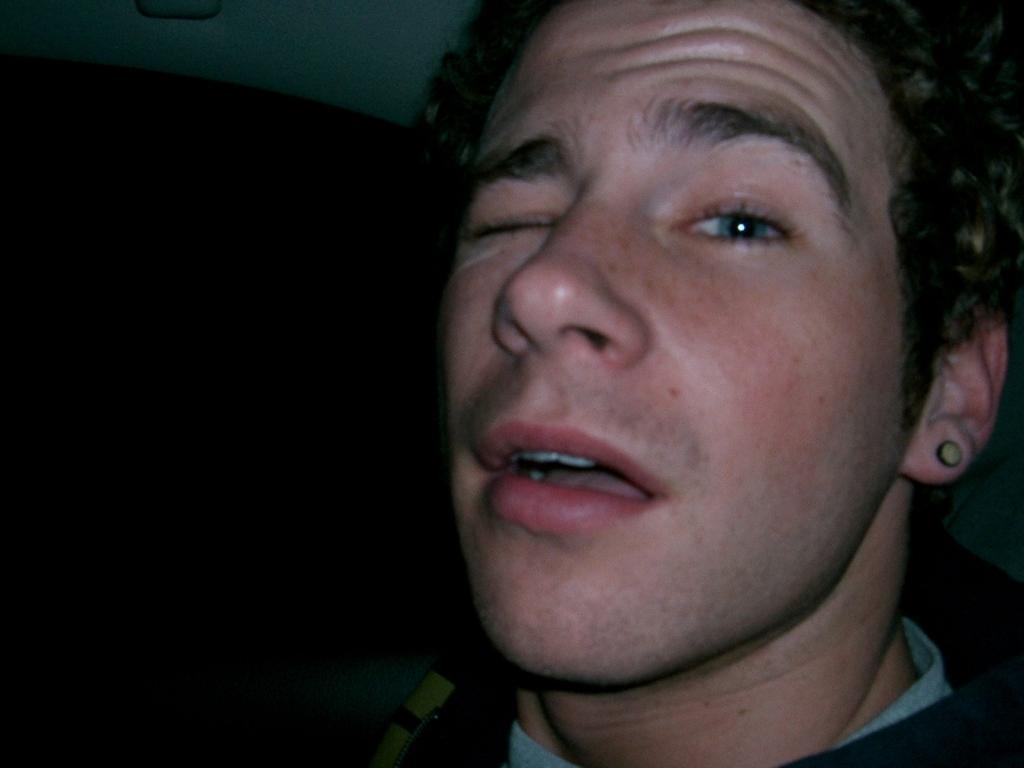Can you describe this image briefly? In this image, we can see a person is winking an eye. 